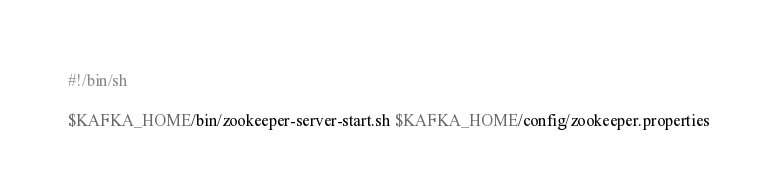<code> <loc_0><loc_0><loc_500><loc_500><_Bash_>#!/bin/sh

$KAFKA_HOME/bin/zookeeper-server-start.sh $KAFKA_HOME/config/zookeeper.properties
</code> 